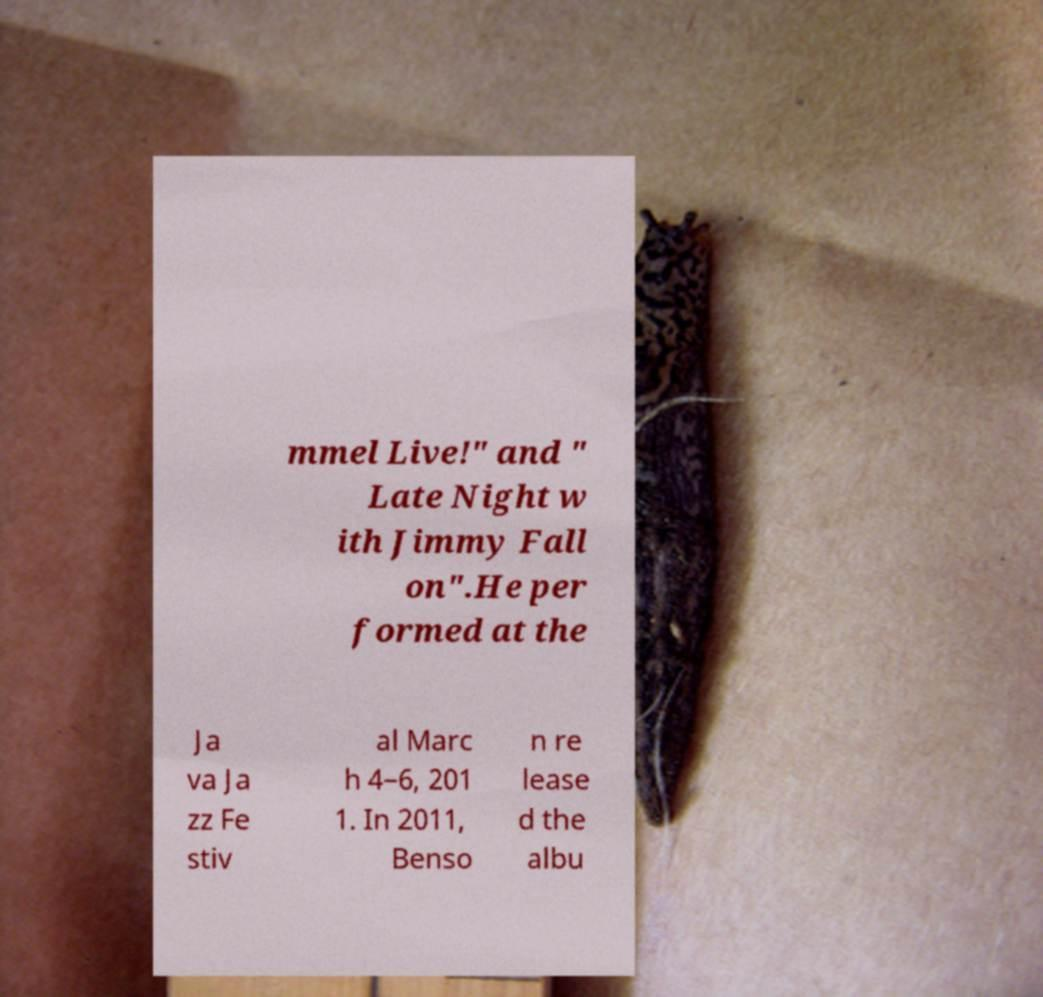Could you assist in decoding the text presented in this image and type it out clearly? mmel Live!" and " Late Night w ith Jimmy Fall on".He per formed at the Ja va Ja zz Fe stiv al Marc h 4–6, 201 1. In 2011, Benso n re lease d the albu 